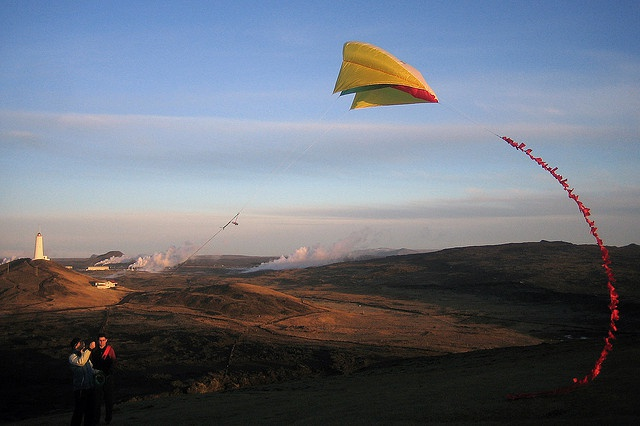Describe the objects in this image and their specific colors. I can see kite in gray, olive, orange, and maroon tones, people in gray, black, orange, and maroon tones, and people in gray, black, maroon, brown, and red tones in this image. 